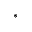Convert formula to latex. <formula><loc_0><loc_0><loc_500><loc_500>^ { \ast }</formula> 